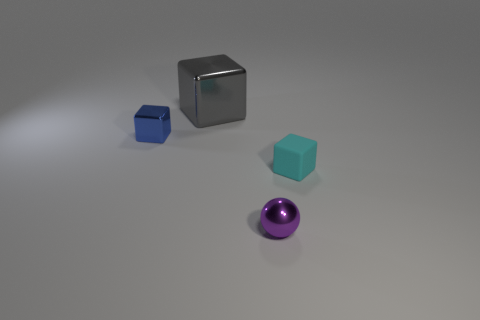What number of cyan metal cylinders have the same size as the sphere? In the image, there are no cyan metal cylinders that match the size of the sphere. The objects present include a cyan cube, a silver cube, and a purple sphere; none of which are cylinders. 